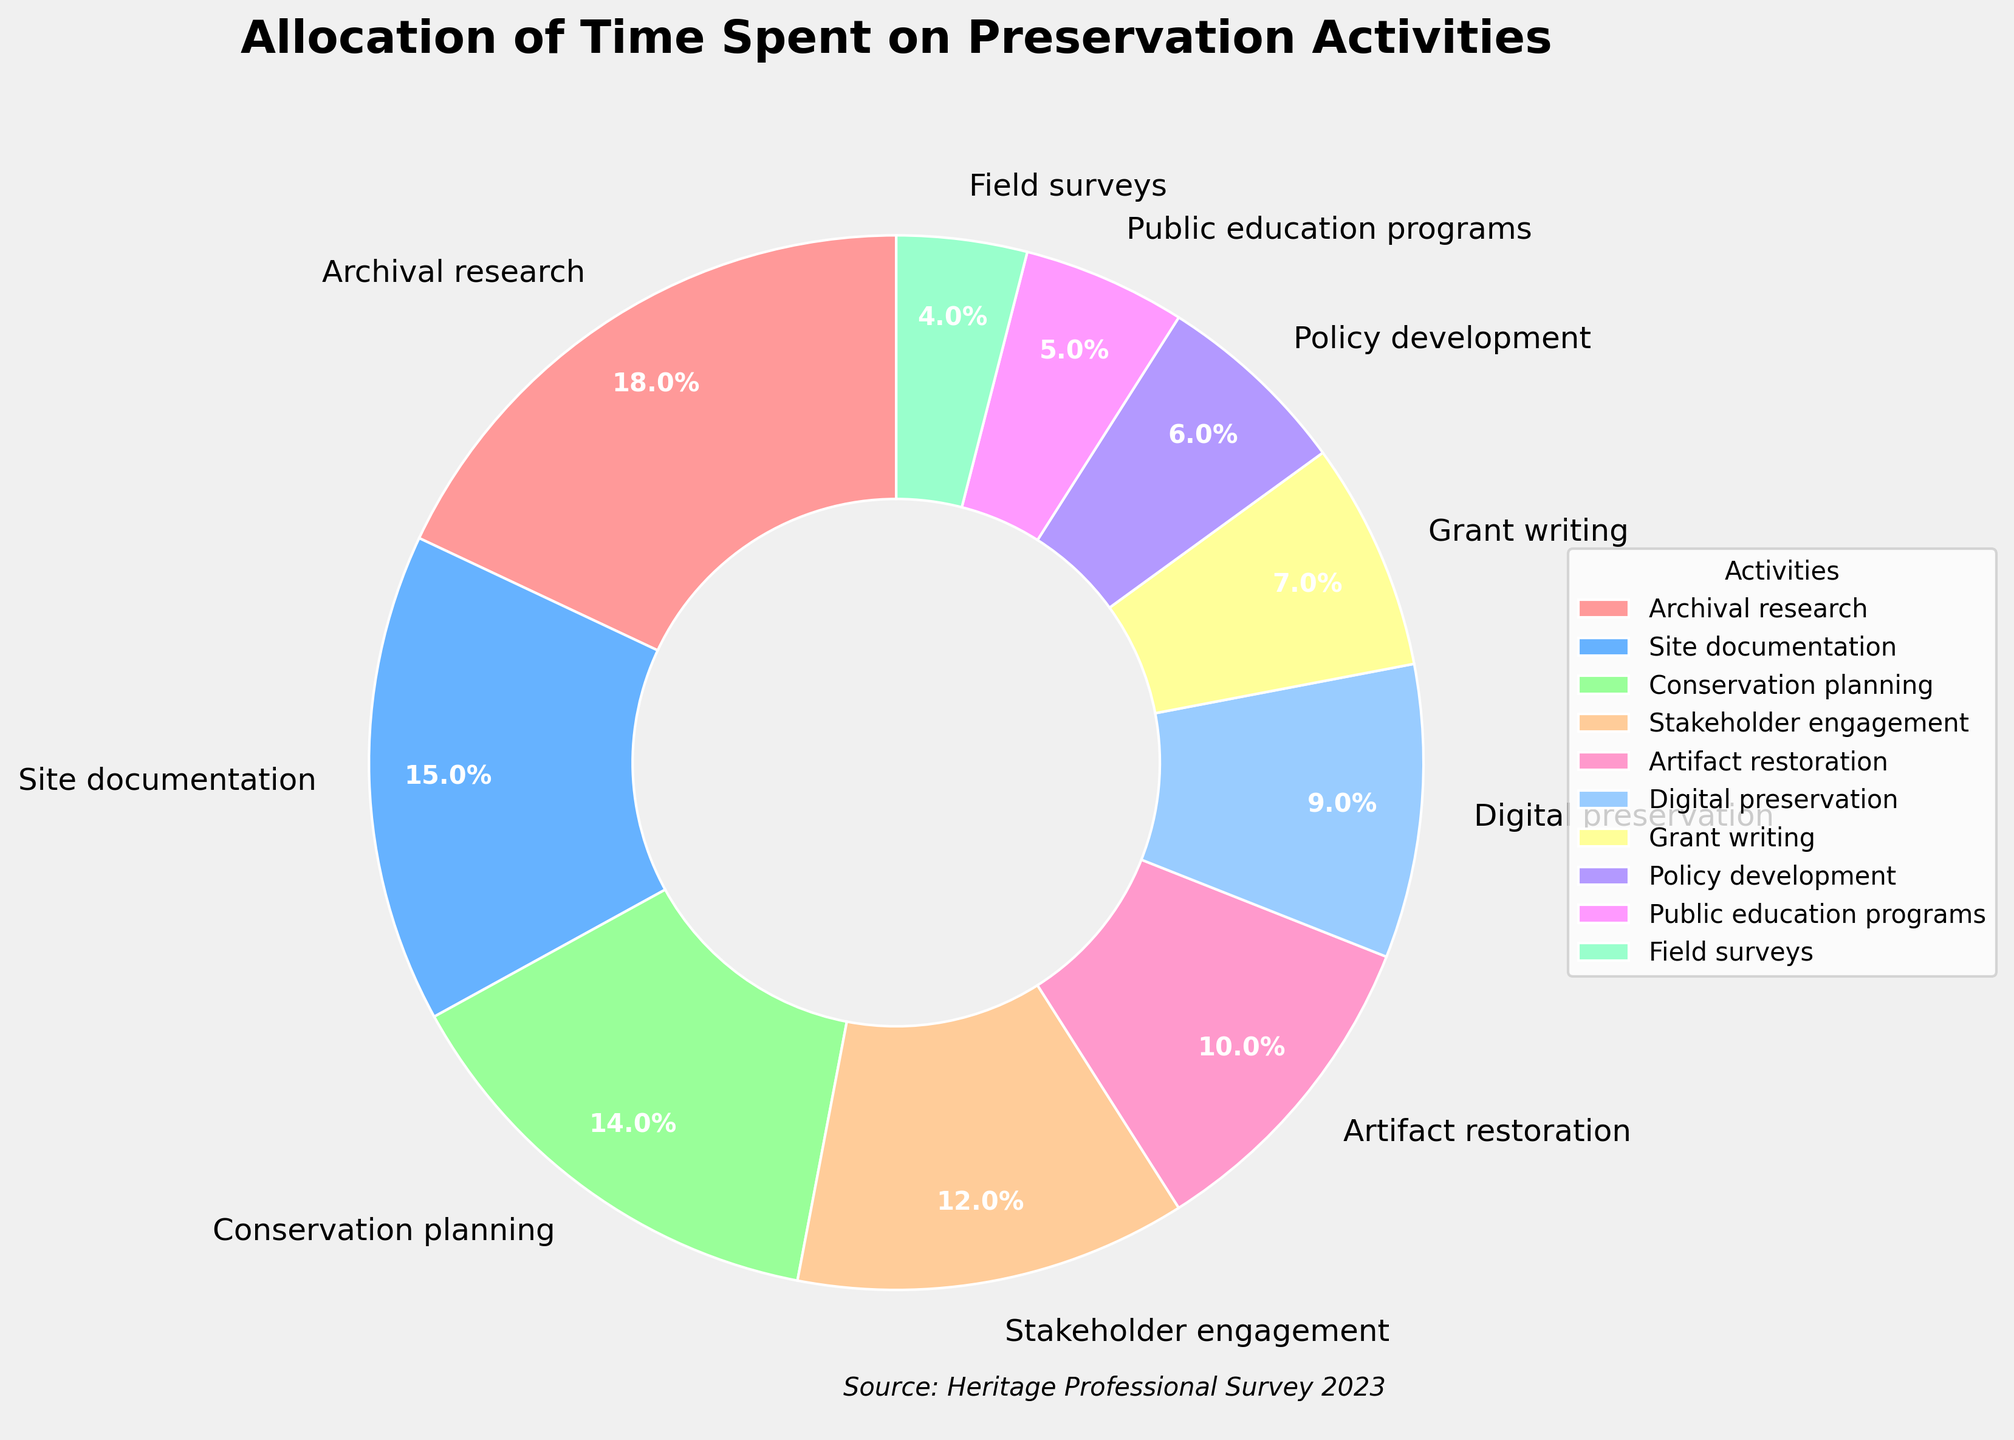Which activity occupies the largest percentage of time? The activity with the highest percentage is labeled as having 18%. This label corresponds to "Archival research."
Answer: Archival research Which activity takes up only 4% of the time? The activity labeled with 4% is "Field surveys."
Answer: Field surveys What is the combined percentage of time spent on Stakeholder engagement and Digital preservation? Stakeholder engagement has 12%, and Digital preservation has 9%. Their combined total is 12% + 9% = 21%.
Answer: 21% Is more time spent on Artifact restoration or Grant writing? Artifact restoration is labeled 10%, and Grant writing is labeled 7%. 10% is greater than 7%, so more time is spent on Artifact restoration.
Answer: Artifact restoration Out of the Policy development and Public education programs, which one has the smaller percentage allocation? Policy development is 6%, and Public education programs are 5%. Since 5% is smaller than 6%, Public education programs have the smaller percentage.
Answer: Public education programs How much more time is spent on Archival research compared to Field surveys? Archival research takes 18% of the time, while Field surveys take 4%. The difference is 18% - 4% = 14%.
Answer: 14% What is the sum of the percentages allocated to Conservation planning, Policy development, and Field surveys? Conservation planning is 14%, Policy development is 6%, and Field surveys are 4%. The total is 14% + 6% + 4% = 24%.
Answer: 24% Which activities together make up exactly half of the total allocation? Archival research (18%), Site documentation (15%), and Conservation planning (14%) together make 18% + 15% + 14% = 47%, while adding Stakeholder engagement (12%) would go past 50%.
Answer: None 